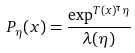<formula> <loc_0><loc_0><loc_500><loc_500>P _ { \eta } ( x ) = \frac { \exp ^ { T ( x ) ^ { \intercal } \eta } } { \lambda ( \eta ) }</formula> 